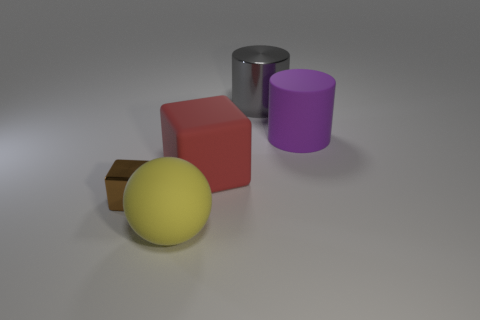Subtract all brown blocks. How many blocks are left? 1 Subtract all cubes. How many objects are left? 3 Subtract 1 balls. How many balls are left? 0 Subtract all metallic spheres. Subtract all yellow things. How many objects are left? 4 Add 3 large yellow rubber things. How many large yellow rubber things are left? 4 Add 4 big red cubes. How many big red cubes exist? 5 Add 1 brown metal blocks. How many objects exist? 6 Subtract 1 red blocks. How many objects are left? 4 Subtract all cyan blocks. Subtract all cyan spheres. How many blocks are left? 2 Subtract all red cylinders. How many green cubes are left? 0 